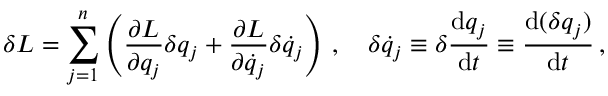Convert formula to latex. <formula><loc_0><loc_0><loc_500><loc_500>\delta L = \sum _ { j = 1 } ^ { n } \left ( { \frac { \partial L } { \partial q _ { j } } } \delta q _ { j } + { \frac { \partial L } { \partial { \dot { q } } _ { j } } } \delta { \dot { q } } _ { j } \right ) \, , \quad \delta { \dot { q } } _ { j } \equiv \delta { \frac { d q _ { j } } { d t } } \equiv \frac { d ( \delta q _ { j } ) } { d t } \, ,</formula> 